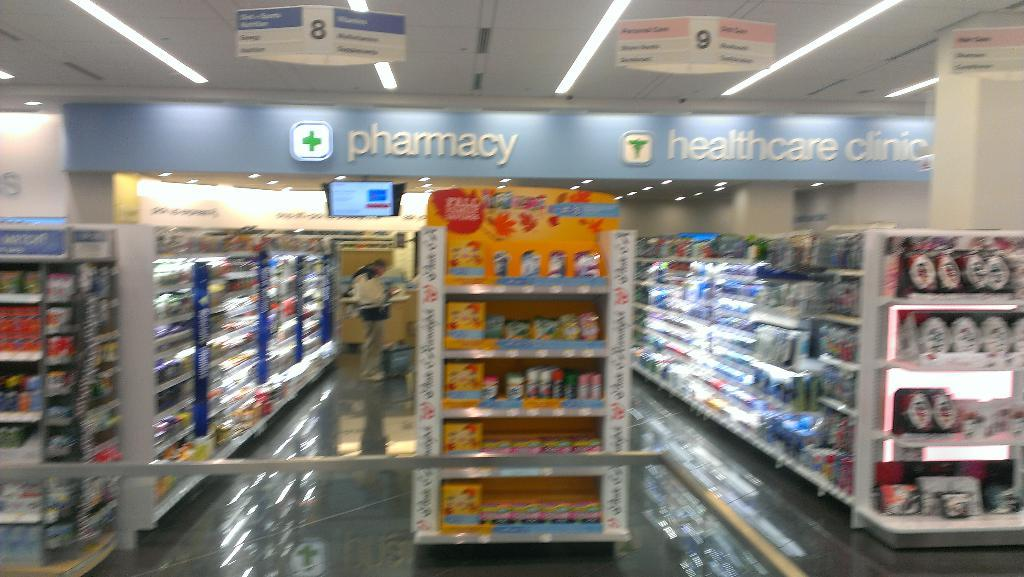<image>
Create a compact narrative representing the image presented. The interior of a pharmacy that also features a healthcare clinic 